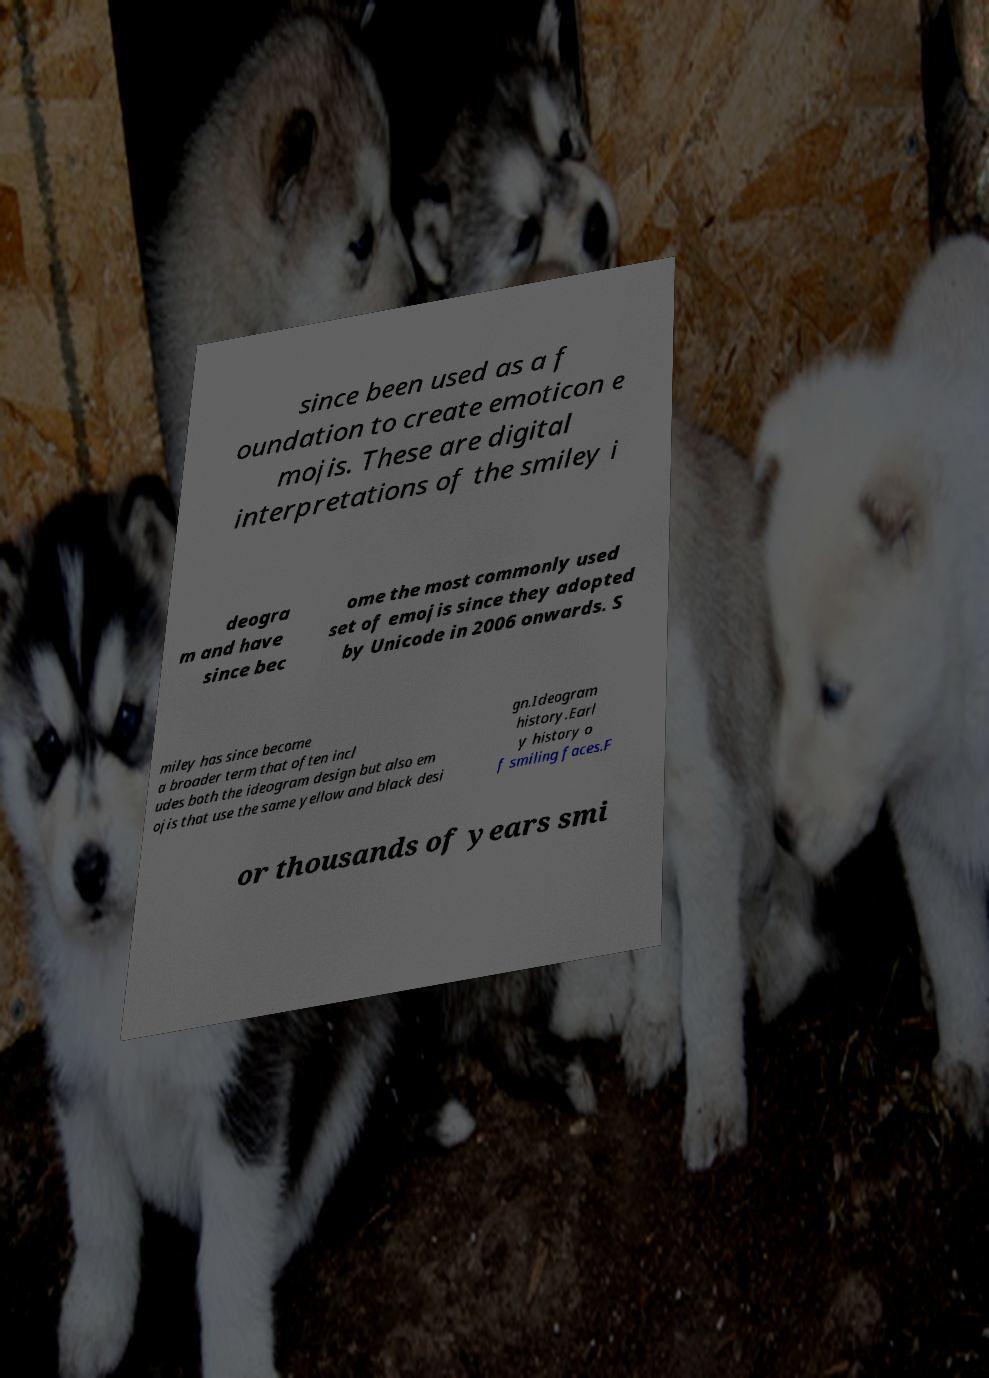Could you extract and type out the text from this image? since been used as a f oundation to create emoticon e mojis. These are digital interpretations of the smiley i deogra m and have since bec ome the most commonly used set of emojis since they adopted by Unicode in 2006 onwards. S miley has since become a broader term that often incl udes both the ideogram design but also em ojis that use the same yellow and black desi gn.Ideogram history.Earl y history o f smiling faces.F or thousands of years smi 